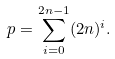Convert formula to latex. <formula><loc_0><loc_0><loc_500><loc_500>p = \sum _ { i = 0 } ^ { 2 n - 1 } ( 2 n ) ^ { i } .</formula> 